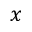Convert formula to latex. <formula><loc_0><loc_0><loc_500><loc_500>x</formula> 